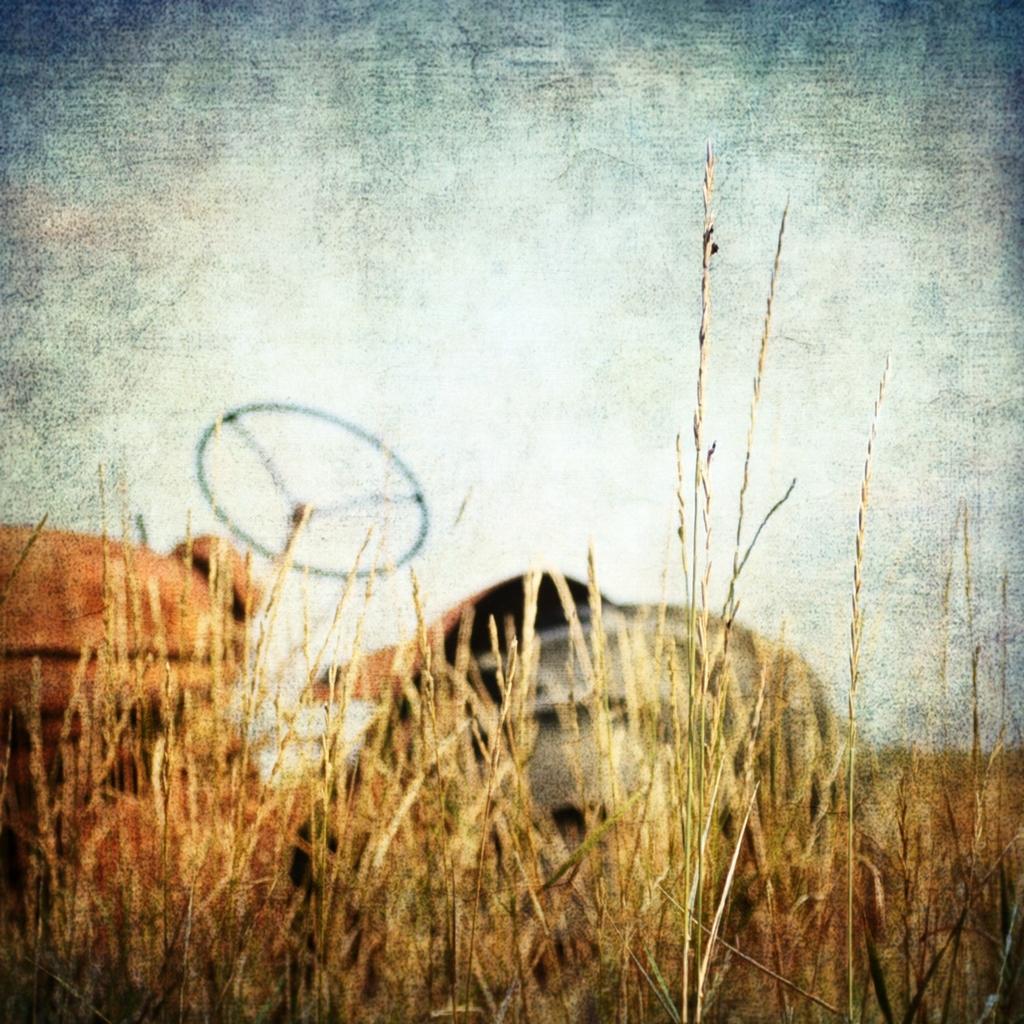Please provide a concise description of this image. In this image in the front there is grass and in the background there is a vehicle. 